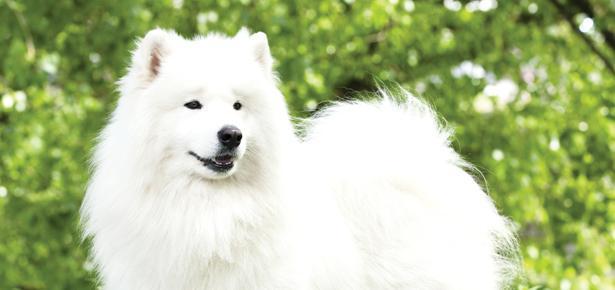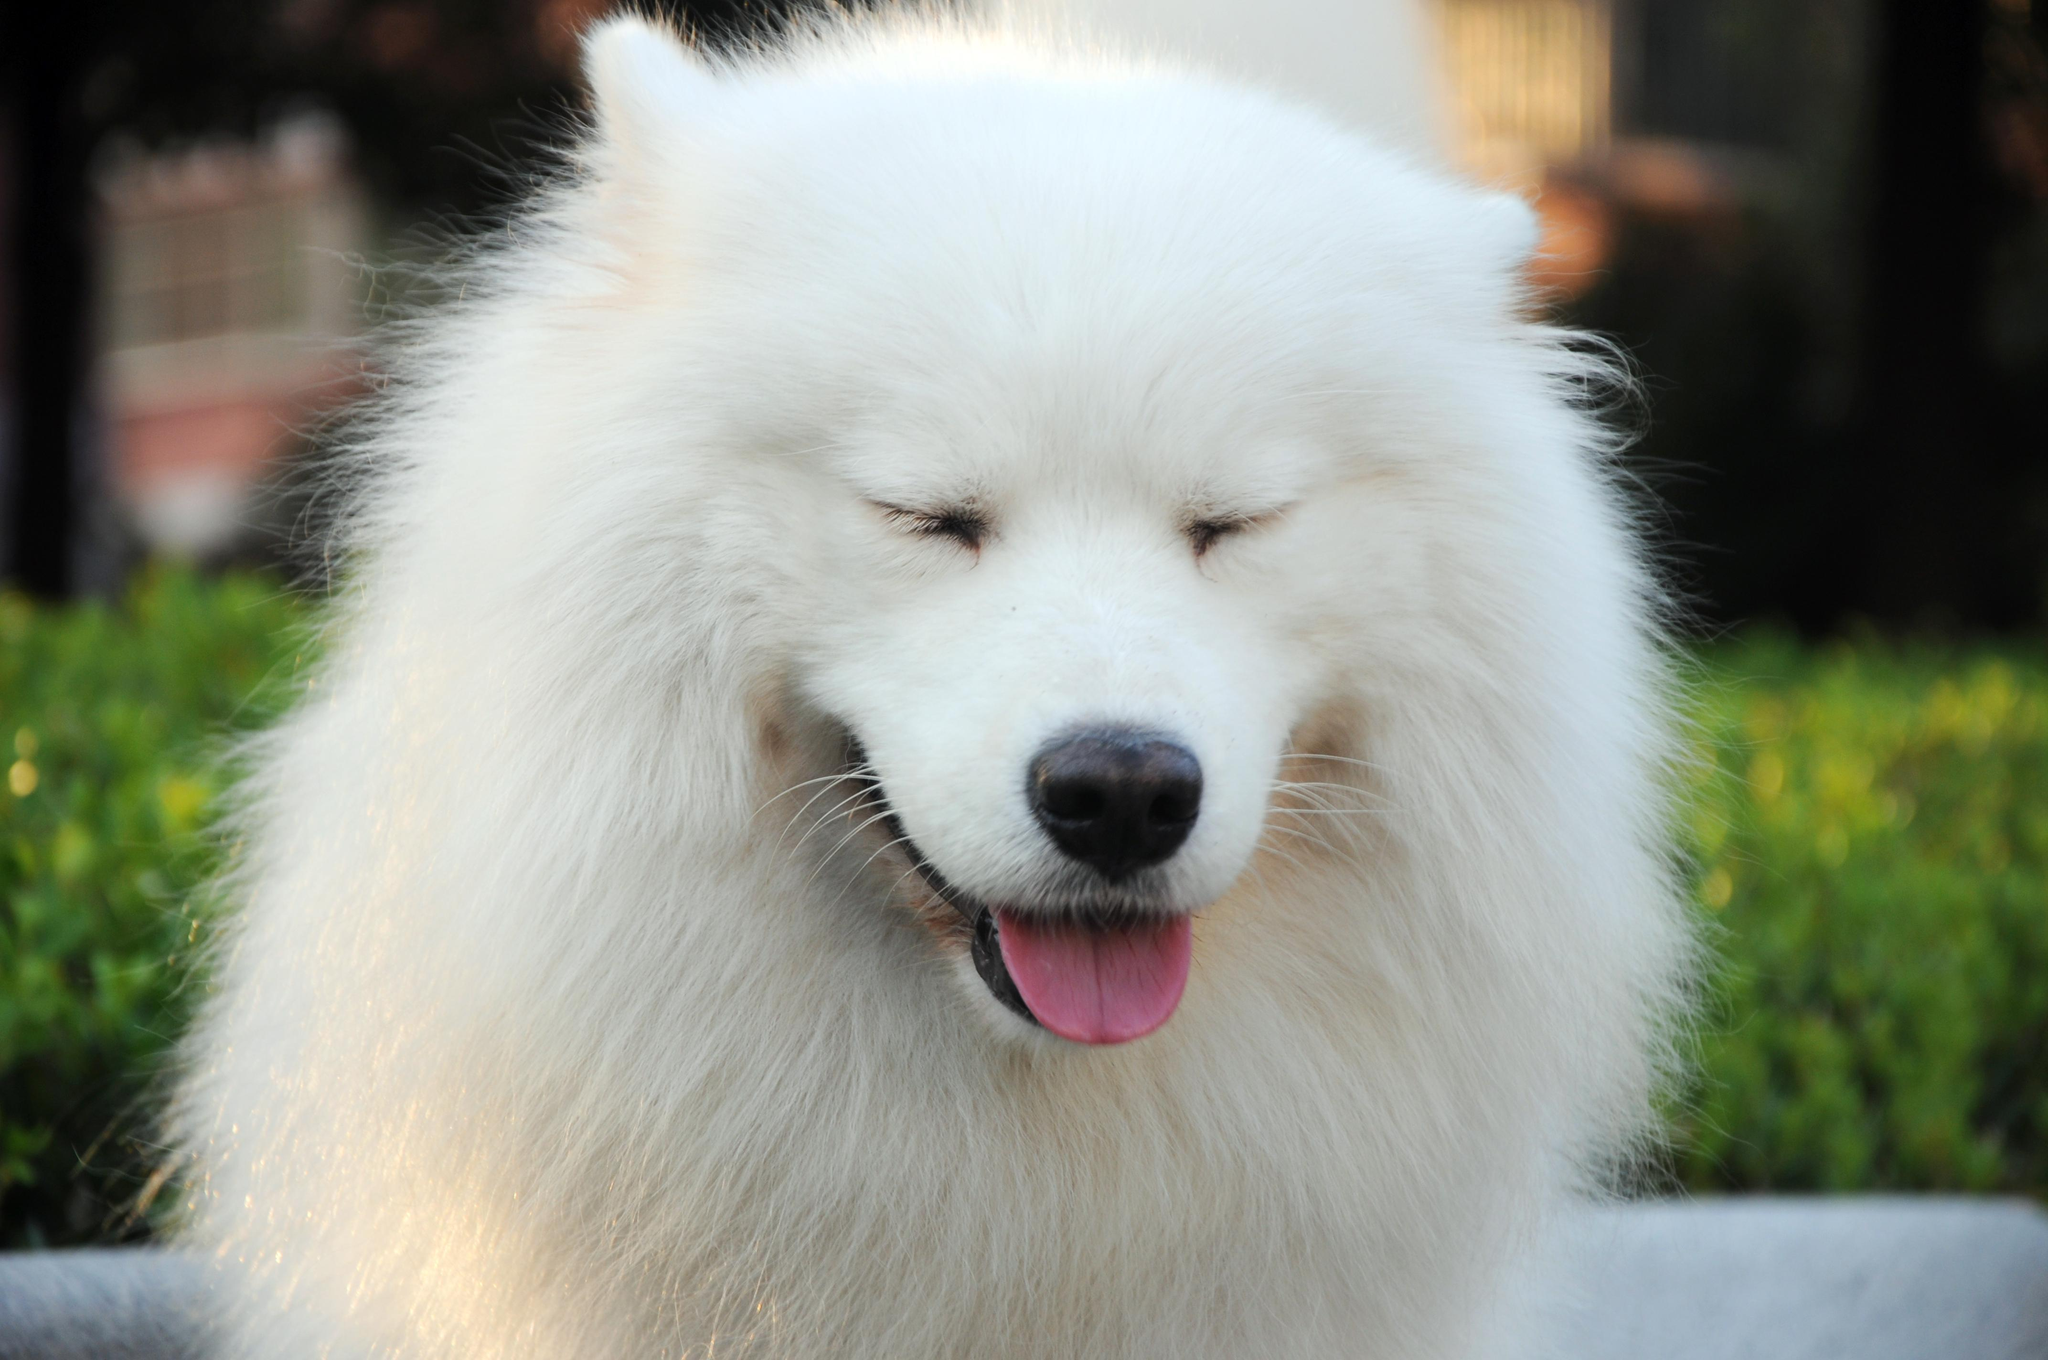The first image is the image on the left, the second image is the image on the right. Analyze the images presented: Is the assertion "There are more dogs in the right image than in the left." valid? Answer yes or no. No. 